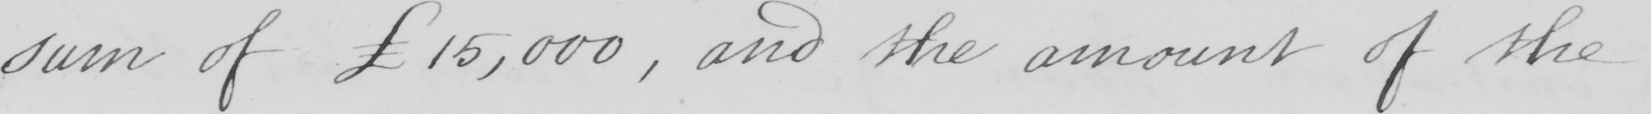Please transcribe the handwritten text in this image. sum of £15,000  , and the amount of the 